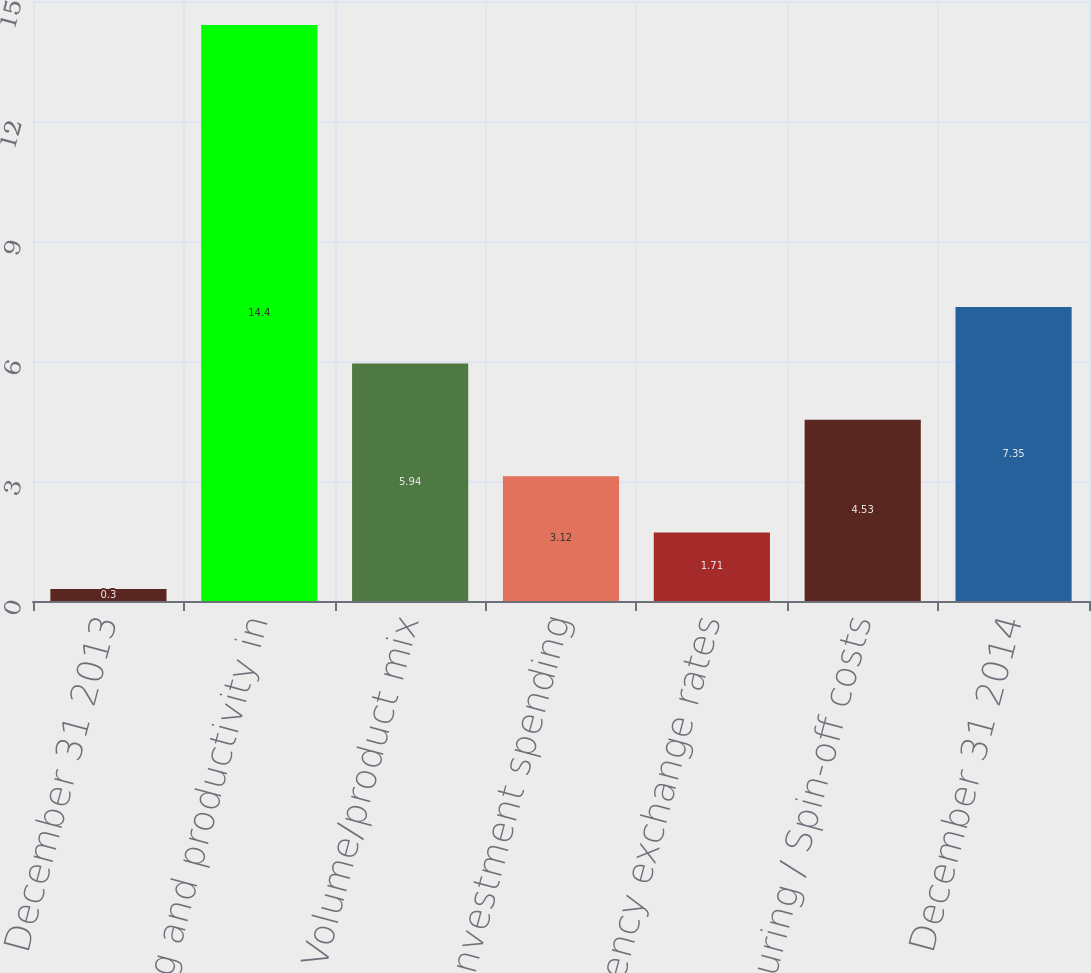<chart> <loc_0><loc_0><loc_500><loc_500><bar_chart><fcel>December 31 2013<fcel>Pricing and productivity in<fcel>Volume/product mix<fcel>Investment spending<fcel>Currency exchange rates<fcel>Restructuring / Spin-off costs<fcel>December 31 2014<nl><fcel>0.3<fcel>14.4<fcel>5.94<fcel>3.12<fcel>1.71<fcel>4.53<fcel>7.35<nl></chart> 